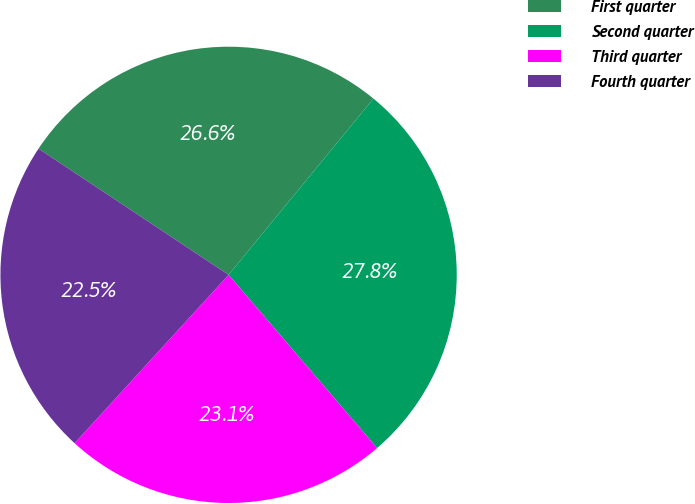Convert chart. <chart><loc_0><loc_0><loc_500><loc_500><pie_chart><fcel>First quarter<fcel>Second quarter<fcel>Third quarter<fcel>Fourth quarter<nl><fcel>26.62%<fcel>27.77%<fcel>23.07%<fcel>22.54%<nl></chart> 